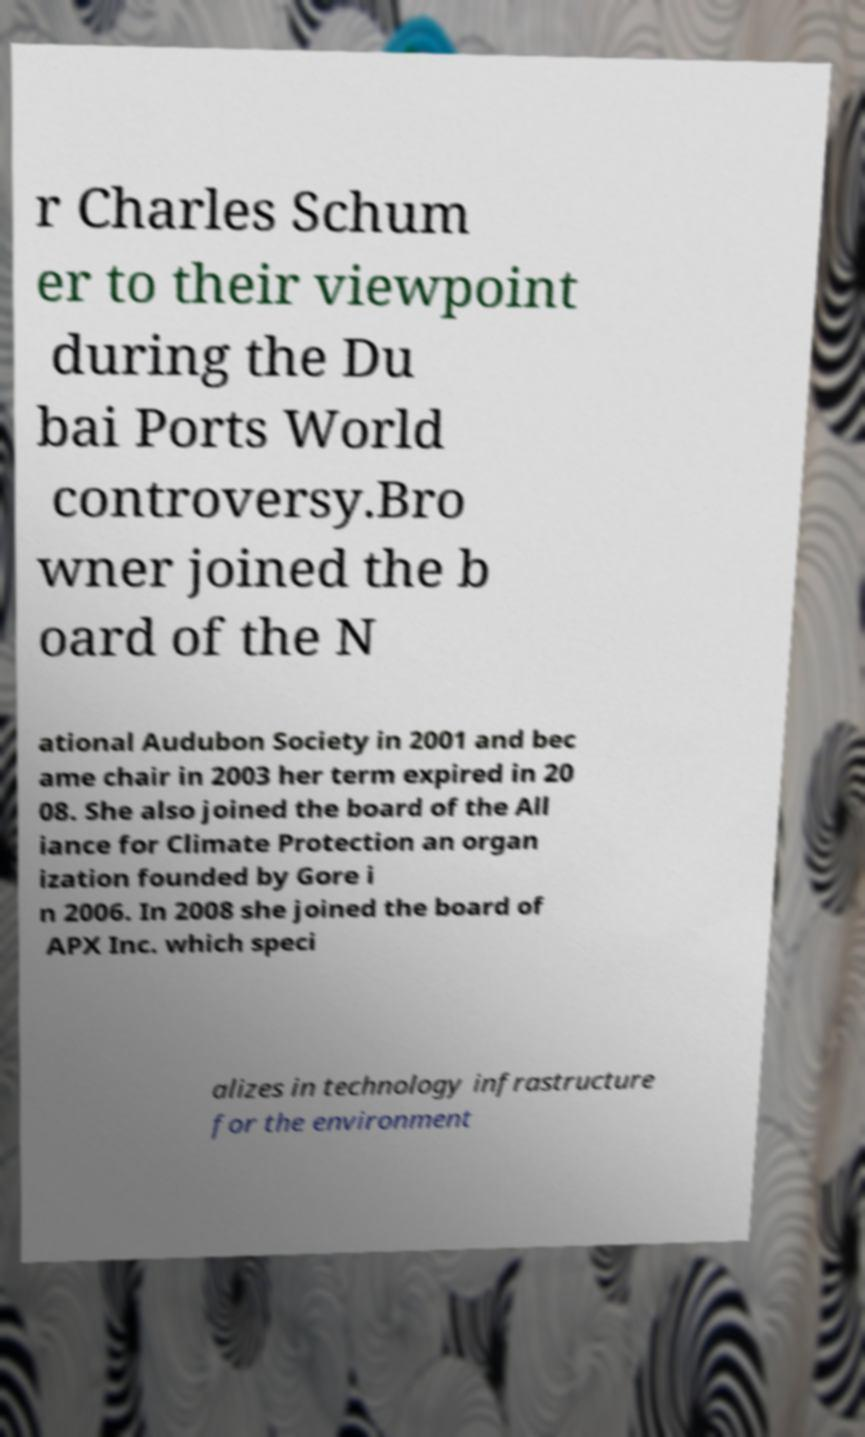Please identify and transcribe the text found in this image. r Charles Schum er to their viewpoint during the Du bai Ports World controversy.Bro wner joined the b oard of the N ational Audubon Society in 2001 and bec ame chair in 2003 her term expired in 20 08. She also joined the board of the All iance for Climate Protection an organ ization founded by Gore i n 2006. In 2008 she joined the board of APX Inc. which speci alizes in technology infrastructure for the environment 